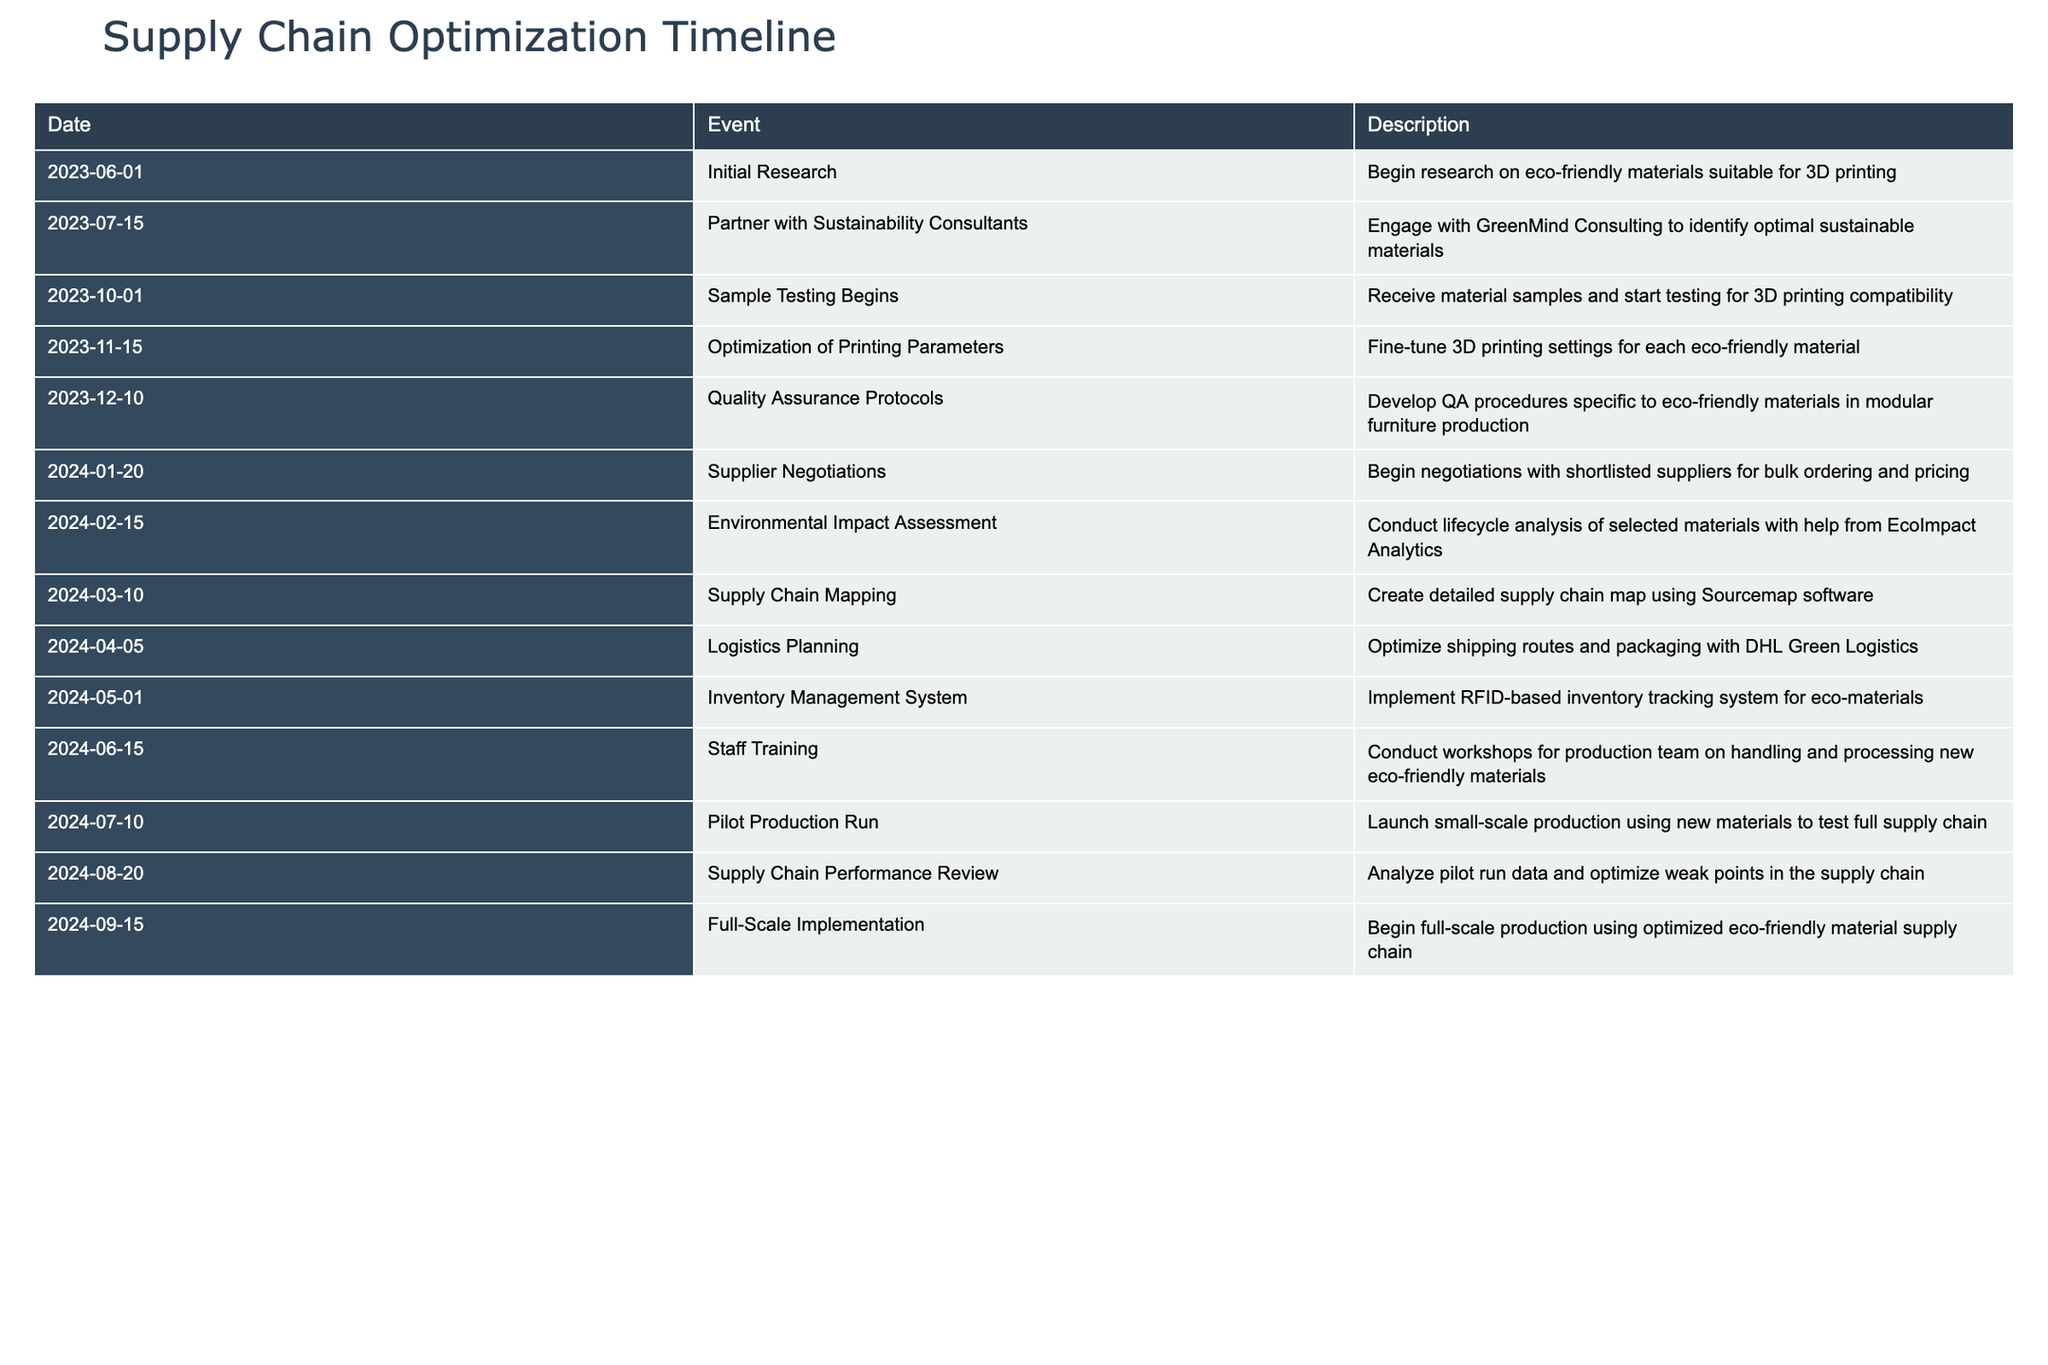What date did the initial research on eco-friendly materials begin? The table lists the date associated with the event "Initial Research," which is clearly listed as 2023-06-01.
Answer: 2023-06-01 What was the last event listed before the full-scale implementation? The event prior to "Full-Scale Implementation" is "Supply Chain Performance Review," which occurred on 2024-08-20, as indicated in the table.
Answer: 2024-08-20 How many months were there between the pilot production run and the full-scale implementation? To find the duration, we look at the dates for "Pilot Production Run" on 2024-07-10 and "Full-Scale Implementation" on 2024-09-15. From July 10 to September 15, there is a little more than 2 months.
Answer: 2 months Was the environmental impact assessment conducted before or after supplier negotiations? By examining the events, "Supplier Negotiations" occurred on 2024-01-20 and "Environmental Impact Assessment" on 2024-02-15. Since 2024-01-20 is earlier than 2024-02-15, the assessment was conducted after the negotiations.
Answer: After What are the two events that occurred in December 2023? Looking at the table, we see "Quality Assurance Protocols" on 2023-12-10 and confirming that there is only one event for December, indicating there weren't two events listed for that month.
Answer: One event only How many total events were planned between June 2023 and June 2024? Counting the number of events between the start date in June 2023 to the end date in June 2024, there are 13 total events listed in the table, confirming this progression from start to finish.
Answer: 13 events What is the event scheduled immediately after the logistics planning? According to the timeline, the event following "Logistics Planning" on 2024-04-05 is "Inventory Management System" on 2024-05-01, as stated clearly in the event sequence.
Answer: Inventory Management System Did the pilot production run happen before or after staff training? The "Pilot Production Run" occurs on 2024-07-10 and "Staff Training" is dated 2024-06-15, showing that the pilot run took place after the staff training was conducted.
Answer: After 